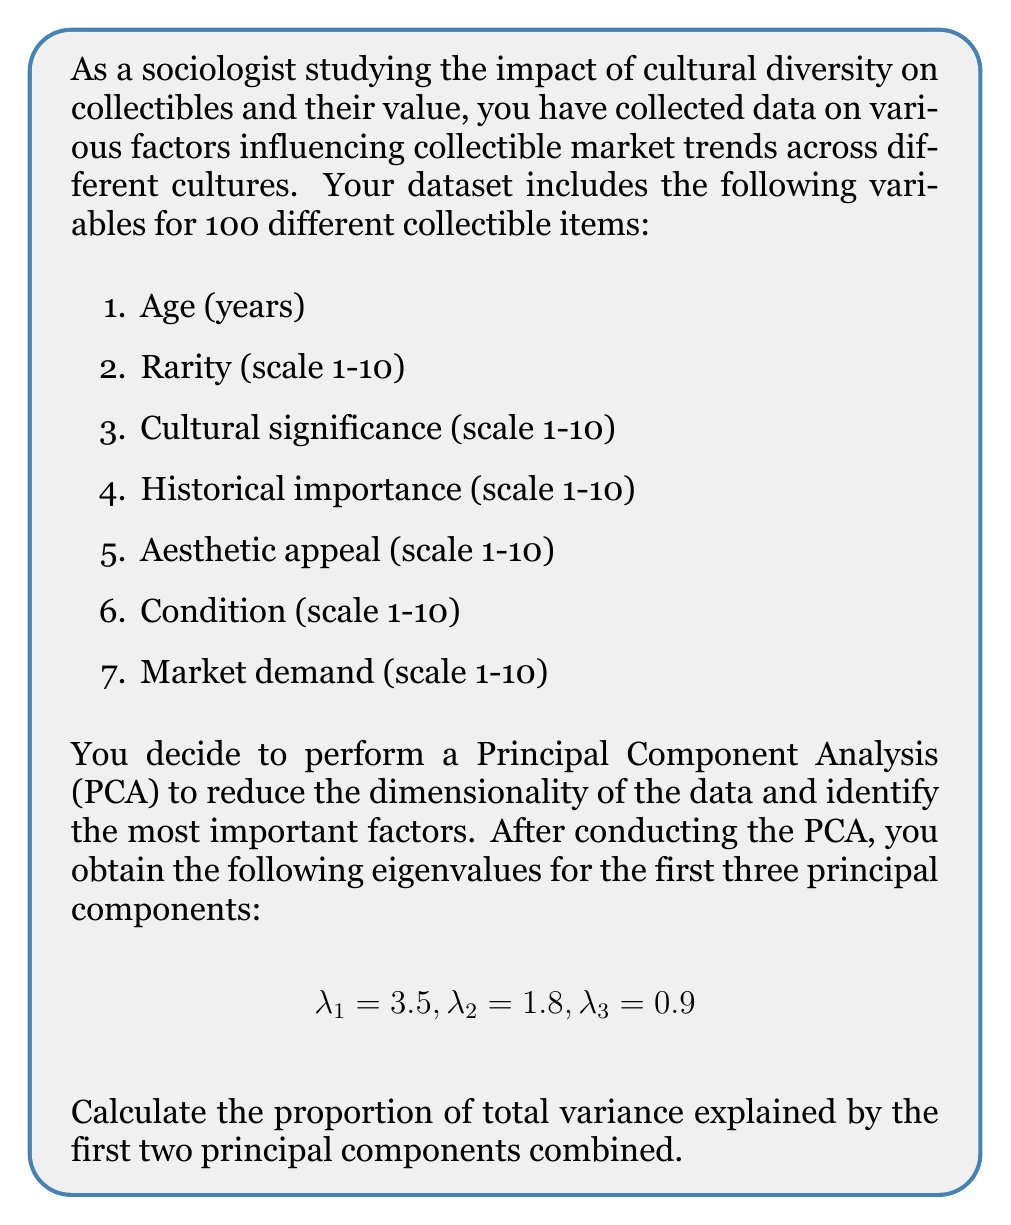Help me with this question. To calculate the proportion of total variance explained by the first two principal components, we need to follow these steps:

1. Calculate the total variance:
   The total variance is the sum of all eigenvalues. In this case, we have 7 variables, so there are 7 eigenvalues in total. We're given the first three, so we'll assume the remaining four are smaller and not significant for this calculation.

   Total variance = $\lambda_1 + \lambda_2 + \lambda_3 + ... + \lambda_7 = 7$ (since there are 7 variables)

2. Calculate the variance explained by the first two principal components:
   Variance explained by PC1 and PC2 = $\lambda_1 + \lambda_2 = 3.5 + 1.8 = 5.3$

3. Calculate the proportion of variance explained:
   Proportion = (Variance explained by PC1 and PC2) / (Total variance)
   
   $$\text{Proportion} = \frac{\lambda_1 + \lambda_2}{\sum_{i=1}^7 \lambda_i} = \frac{5.3}{7} = 0.7571$$

4. Convert to percentage:
   Percentage of variance explained = $0.7571 \times 100\% = 75.71\%$

Therefore, the first two principal components combined explain 75.71% of the total variance in the dataset.
Answer: 75.71% 